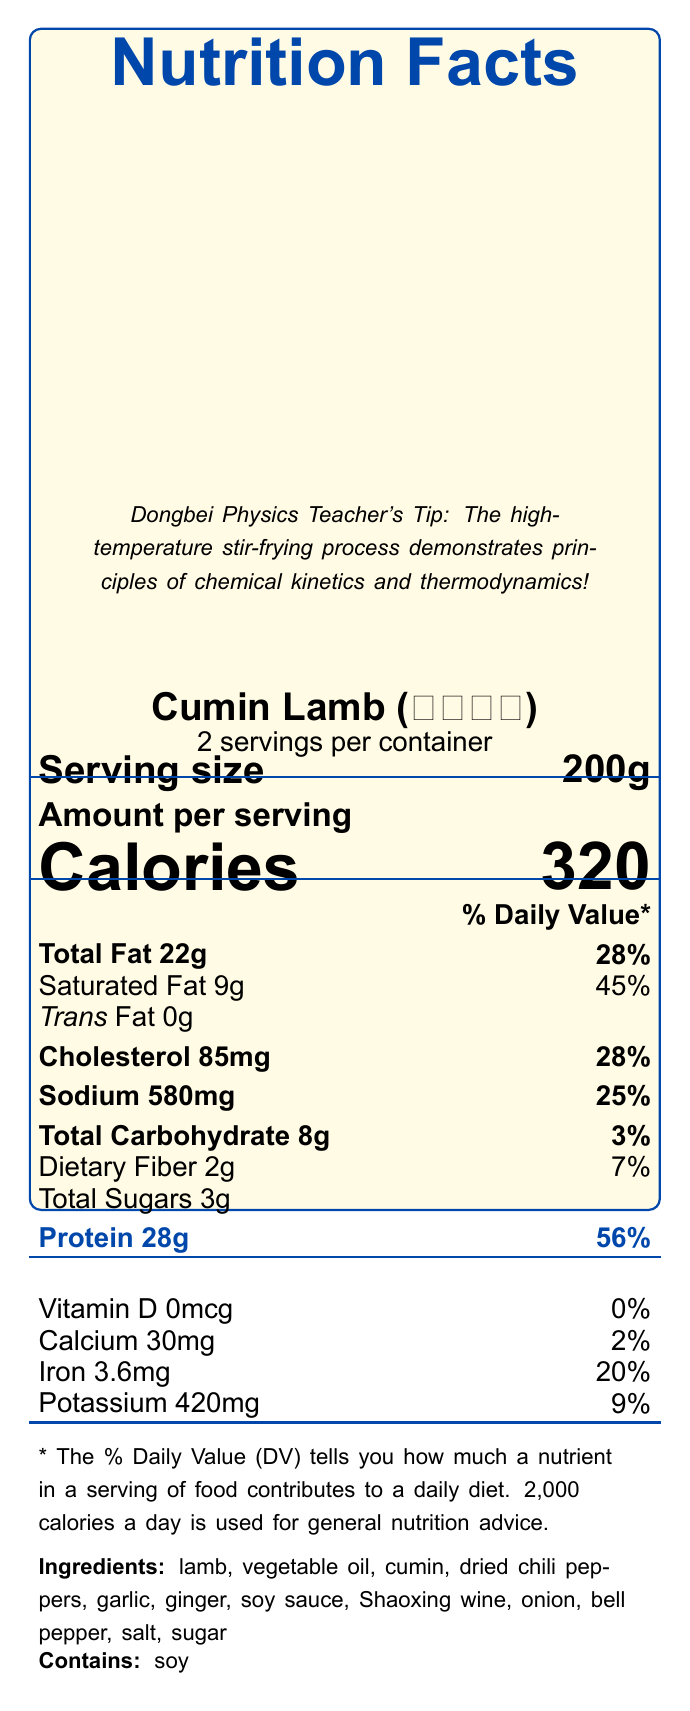What is the serving size for Cumin Lamb (孜然羊肉)? The serving size is directly stated in the document as "Serving size: 200g".
Answer: 200g How many servings are there per container? The document states "2 servings per container" near the top under the dish name.
Answer: 2 servings How many calories are in one serving of Cumin Lamb? The document specifically mentions "Calories: 320" under the "Amount per serving" section.
Answer: 320 calories How much protein is in one serving of this dish? Under the nutrition facts, it lists "Protein: 28g" one serving.
Answer: 28g What is the % Daily Value for iron in one serving? The % Daily Value for iron is listed as "Iron 3.6mg 20%" on the nutrition label.
Answer: 20% What are the main ingredients of Cumin Lamb (孜然羊肉)? A. lamb, vegetable oil, cumin, dried chili peppers B. lamb, vegetable oil, soy sauce, onions C. lamb, vegetable oil, cumin, Shaoxing wine D. all of the above The document lists all ingredients including "lamb, vegetable oil, cumin, dried chili peppers, garlic, ginger, soy sauce, Shaoxing wine, onion, bell pepper, salt, sugar".
Answer: D How much total fat is in one serving? The total fat content is listed as "Total Fat 22g" on the label.
Answer: 22g Which nutrient is present in the highest amount by % Daily Value in one serving? A. Saturated Fat B. Cholesterol C. Protein D. Sodium The % Daily Value for protein is stated as 56%, which is higher than Saturated Fat (45%), Cholesterol (28%), and Sodium (25%).
Answer: C Does this dish contain vitamin D? The document states "Vitamin D 0mcg" and "0%" indicating no vitamin D content.
Answer: No Explain the significance of the Maillard reaction in the preparation of this dish. The document notes that the high-temperature stir-frying causes the Maillard reaction, thus explaining the principle of how flavor is developed through chemical processes.
Answer: The Maillard reaction creates complex flavors and browns the meat, demonstrating chemical kinetics and thermodynamics. Summarize the nutrition and preparation details of Cumin Lamb (孜然羊肉). The document provides an overview of the nutrition facts, ingredients, allergens, preparation method, and some scientific context around the Maillard reaction for flavor development.
Answer: The dish is high in protein (28g, 56% DV) and calories (320 per serving). It contains notable amounts of fat, sodium, and iron, with low carbohydrates and no vitamin D. Ingredients include lamb, oil, spices, and others, and it’s prepared by stir-frying. How many grams of dietary fiber does one serving contain? Under the Total Carbohydrate section, it lists "Dietary Fiber 2g".
Answer: 2g What is the % Daily Value of sodium per serving? The label lists sodium as 580mg and 25% Daily Value.
Answer: 25% List an allergen found in this dish. The document states "Contains: soy" under the allergen section.
Answer: Soy Can we determine how much Shaoxing wine is used in the dish from the document? The document lists Shaoxing wine as an ingredient but doesn't specify the quantity.
Answer: Cannot be determined Does this dish provide calcium? The document lists "Calcium 30mg" which corresponds to 2% Daily Value, indicating that the dish does contain calcium.
Answer: Yes 